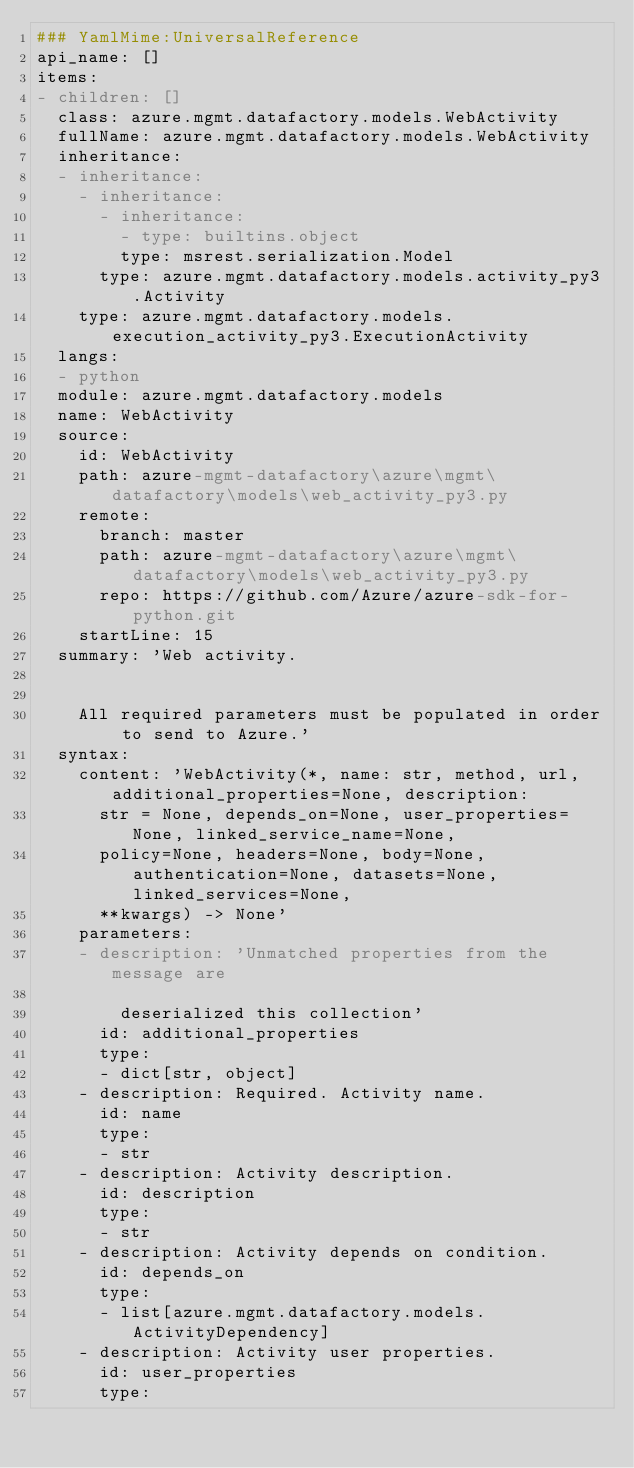Convert code to text. <code><loc_0><loc_0><loc_500><loc_500><_YAML_>### YamlMime:UniversalReference
api_name: []
items:
- children: []
  class: azure.mgmt.datafactory.models.WebActivity
  fullName: azure.mgmt.datafactory.models.WebActivity
  inheritance:
  - inheritance:
    - inheritance:
      - inheritance:
        - type: builtins.object
        type: msrest.serialization.Model
      type: azure.mgmt.datafactory.models.activity_py3.Activity
    type: azure.mgmt.datafactory.models.execution_activity_py3.ExecutionActivity
  langs:
  - python
  module: azure.mgmt.datafactory.models
  name: WebActivity
  source:
    id: WebActivity
    path: azure-mgmt-datafactory\azure\mgmt\datafactory\models\web_activity_py3.py
    remote:
      branch: master
      path: azure-mgmt-datafactory\azure\mgmt\datafactory\models\web_activity_py3.py
      repo: https://github.com/Azure/azure-sdk-for-python.git
    startLine: 15
  summary: 'Web activity.


    All required parameters must be populated in order to send to Azure.'
  syntax:
    content: 'WebActivity(*, name: str, method, url, additional_properties=None, description:
      str = None, depends_on=None, user_properties=None, linked_service_name=None,
      policy=None, headers=None, body=None, authentication=None, datasets=None, linked_services=None,
      **kwargs) -> None'
    parameters:
    - description: 'Unmatched properties from the message are

        deserialized this collection'
      id: additional_properties
      type:
      - dict[str, object]
    - description: Required. Activity name.
      id: name
      type:
      - str
    - description: Activity description.
      id: description
      type:
      - str
    - description: Activity depends on condition.
      id: depends_on
      type:
      - list[azure.mgmt.datafactory.models.ActivityDependency]
    - description: Activity user properties.
      id: user_properties
      type:</code> 